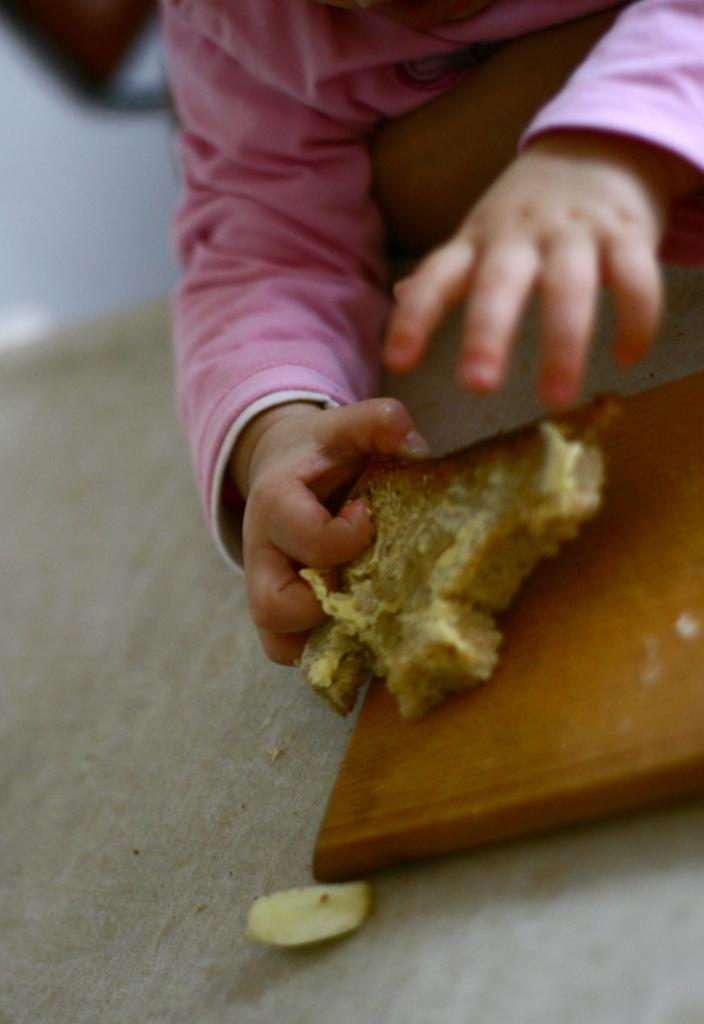What is the main subject of the image? The main subject of the image is a child. What is the child holding in the image? The child is holding a piece of bread. Where is the piece of bread placed in the image? The piece of bread is placed on a table. What type of grain can be seen growing in the image? There is no grain visible in the image. How many hands are visible holding the piece of bread in the image? There is only one set of hands visible holding the piece of bread in the image. What type of sheet is covering the table in the image? There is no sheet covering the table in the image. 